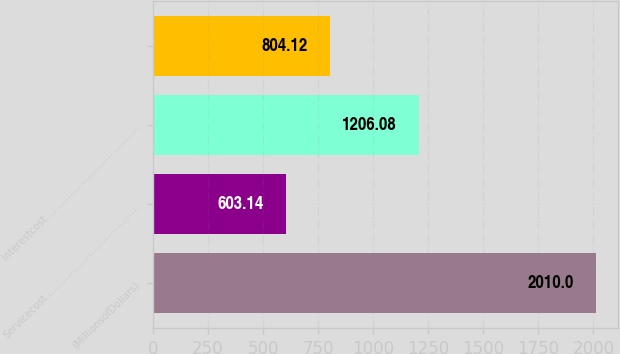Convert chart. <chart><loc_0><loc_0><loc_500><loc_500><bar_chart><fcel>(MillionsofDollars)<fcel>Servicecost…………………………………<fcel>Interestcost…………………………………<fcel>Unnamed: 3<nl><fcel>2010<fcel>603.14<fcel>1206.08<fcel>804.12<nl></chart> 